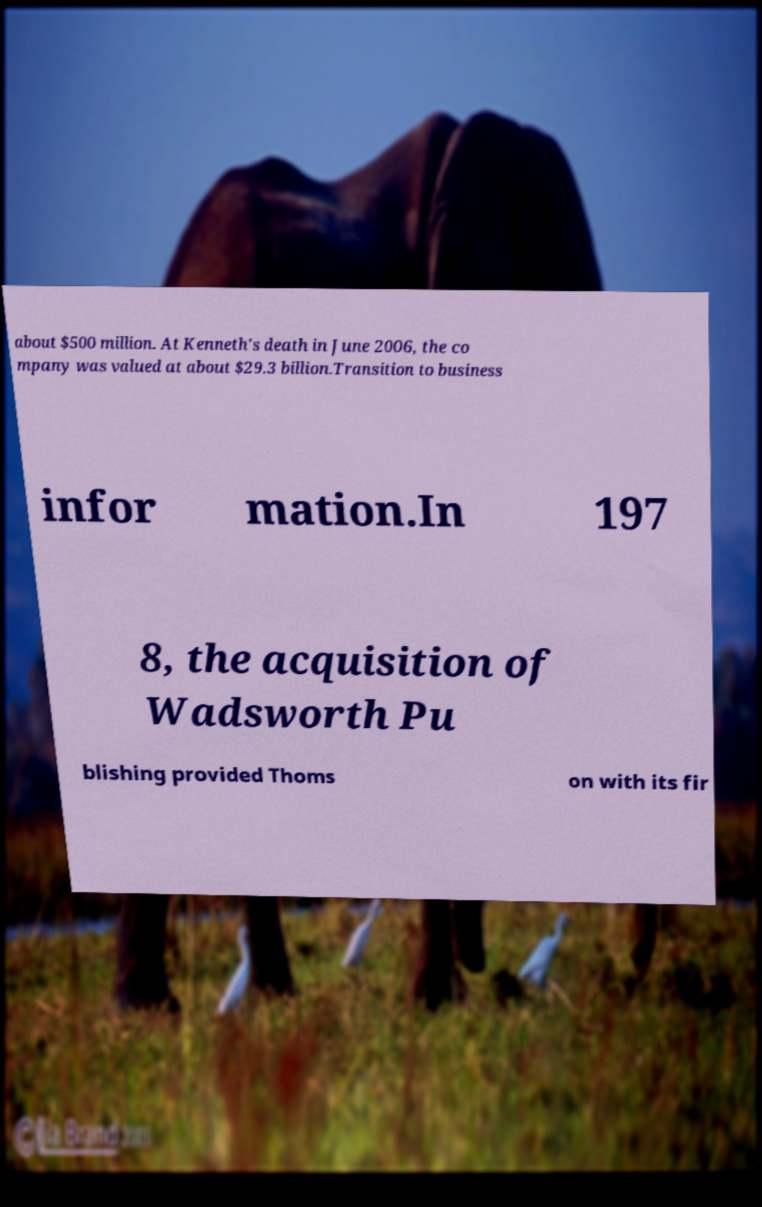What messages or text are displayed in this image? I need them in a readable, typed format. about $500 million. At Kenneth's death in June 2006, the co mpany was valued at about $29.3 billion.Transition to business infor mation.In 197 8, the acquisition of Wadsworth Pu blishing provided Thoms on with its fir 